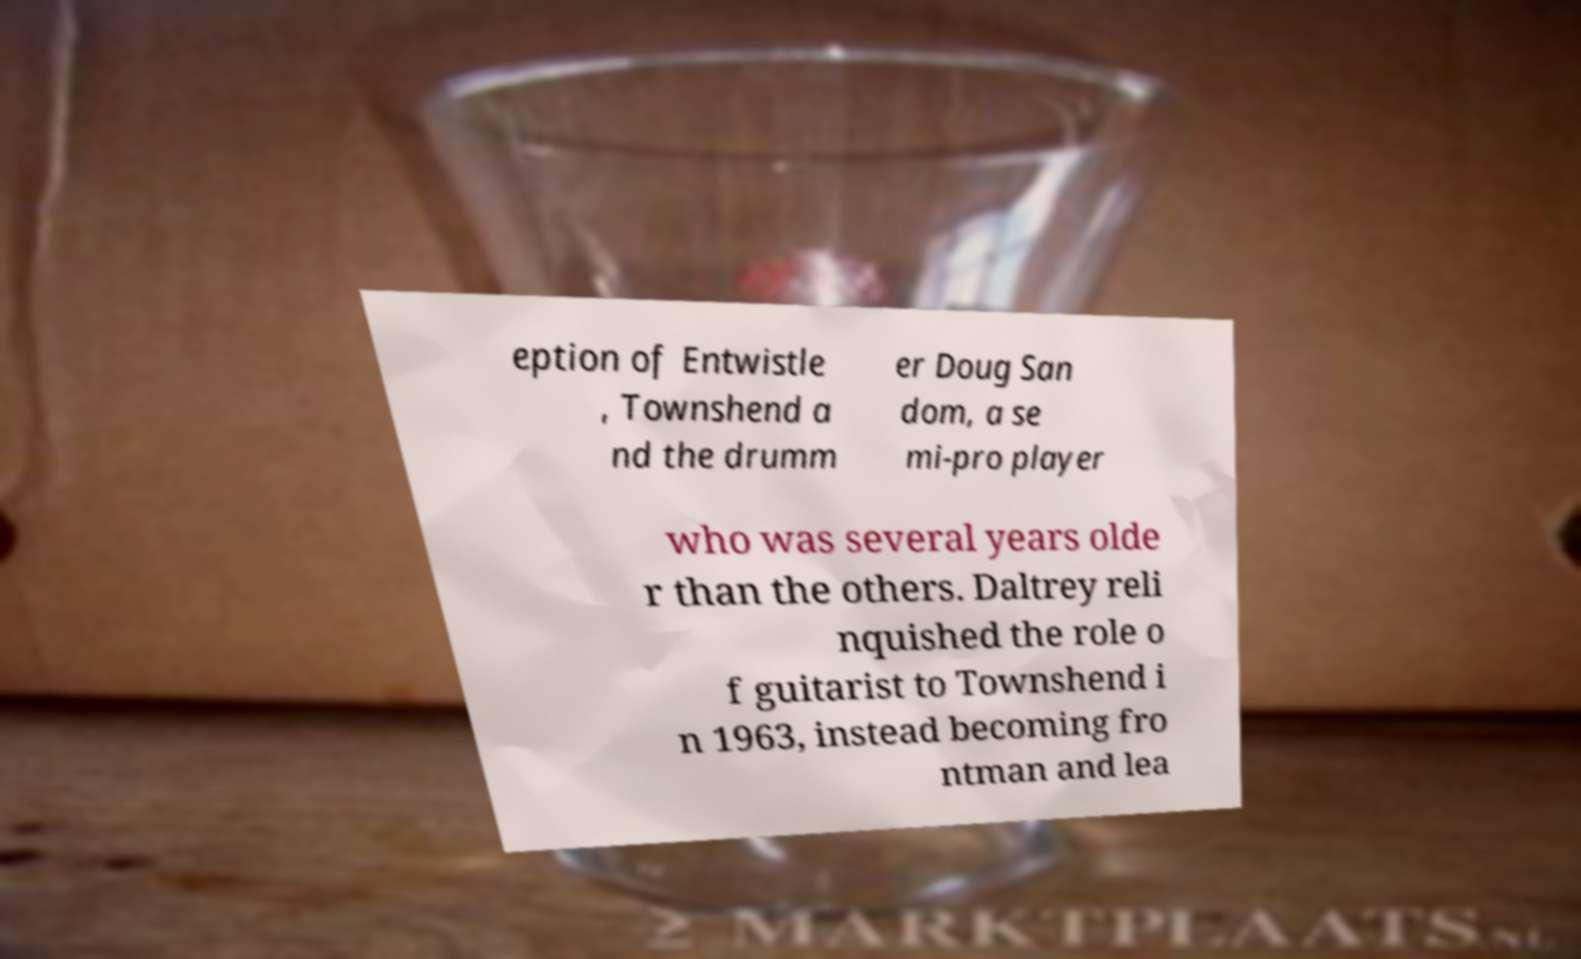What messages or text are displayed in this image? I need them in a readable, typed format. eption of Entwistle , Townshend a nd the drumm er Doug San dom, a se mi-pro player who was several years olde r than the others. Daltrey reli nquished the role o f guitarist to Townshend i n 1963, instead becoming fro ntman and lea 